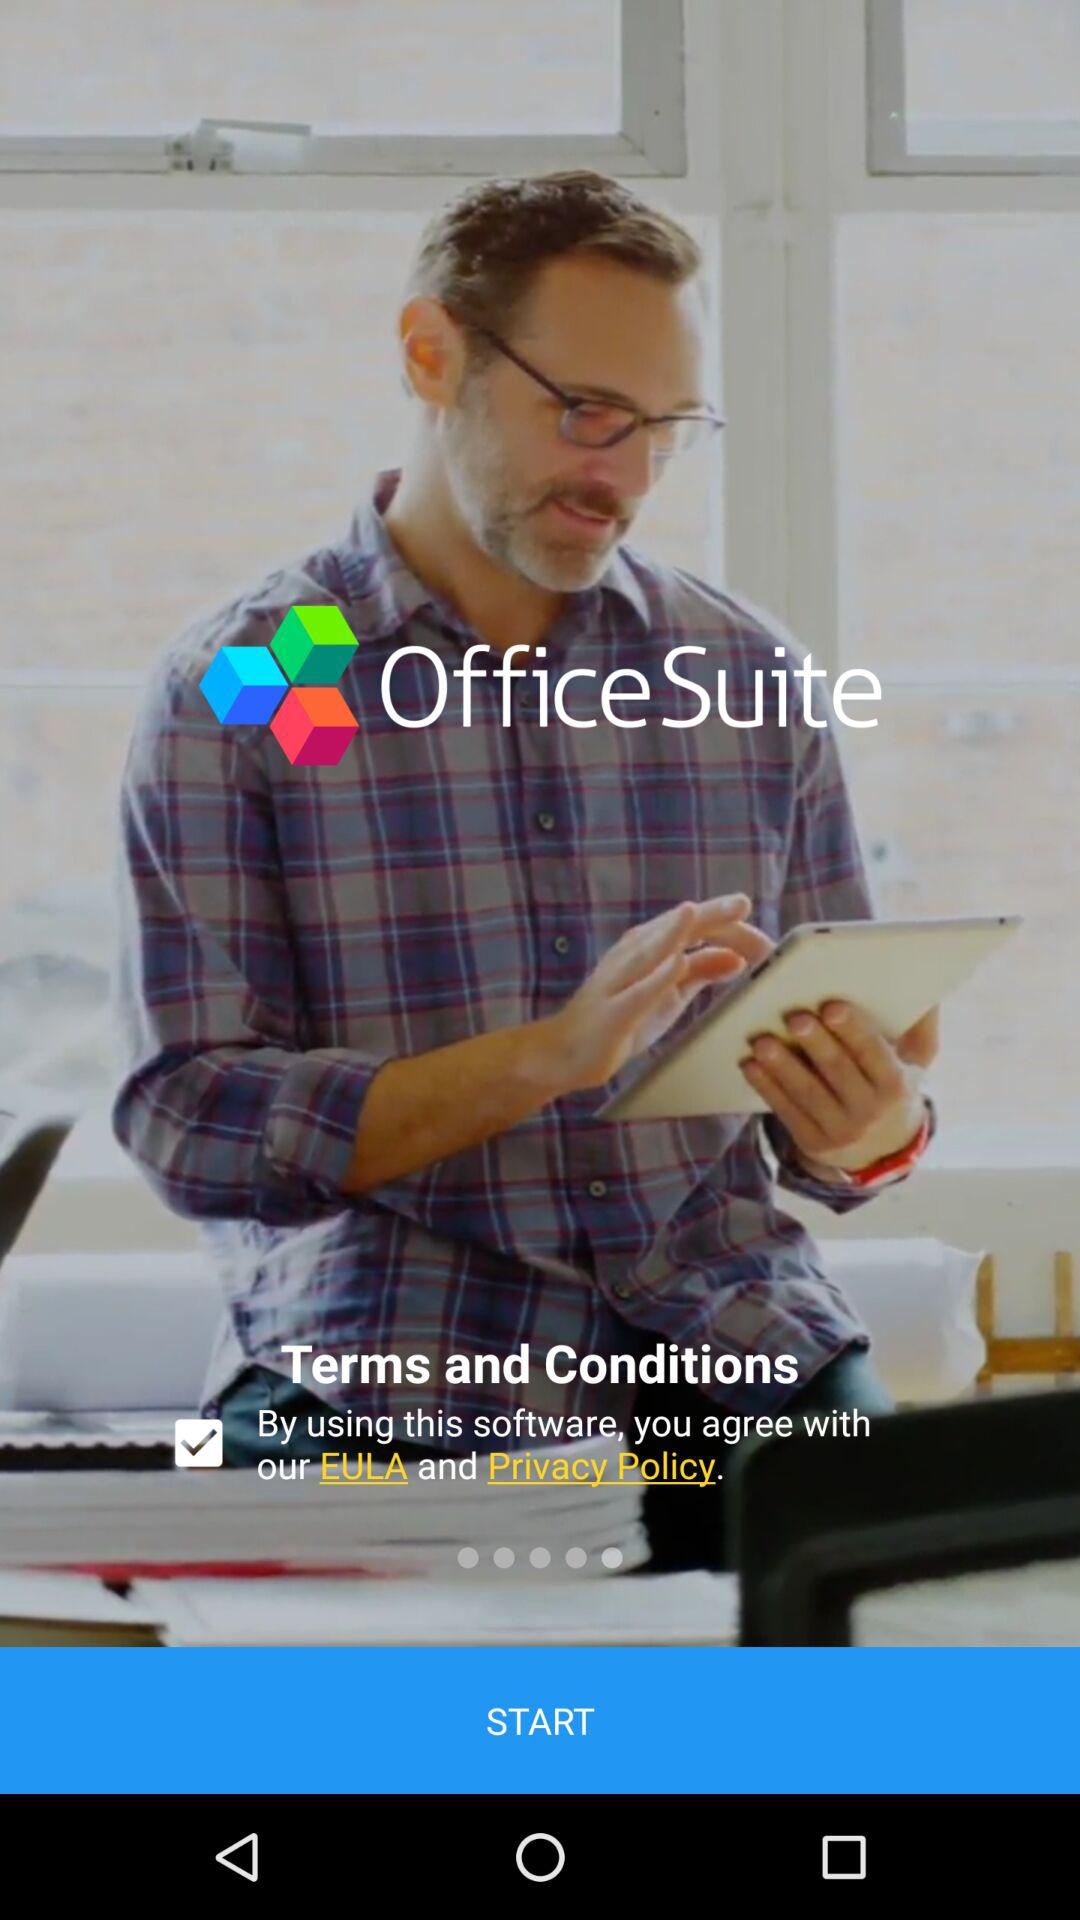What is the name of the application? The name of the application is "Office Suite". 